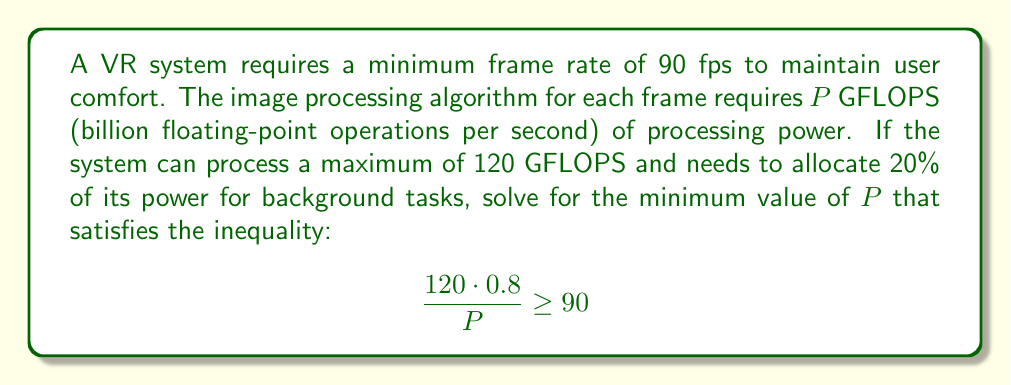Show me your answer to this math problem. Let's solve this step-by-step:

1) First, let's interpret the inequality:
   - 120 GFLOPS is the total processing power
   - 0.8 (or 80%) is the portion available for frame processing
   - $P$ is the processing power required per frame
   - The left side of the inequality represents frames per second
   - 90 is the minimum required frame rate

2) Simplify the left side of the inequality:
   $$\frac{120 \cdot 0.8}{P} \geq 90$$
   $$\frac{96}{P} \geq 90$$

3) Multiply both sides by $P$:
   $$96 \geq 90P$$

4) Divide both sides by 90:
   $$\frac{96}{90} \geq P$$

5) Simplify:
   $$1.0666... \geq P$$

6) Since we're looking for the minimum value of $P$ that satisfies this inequality, we take the upper bound of this result.

7) Round to 3 decimal places for practical purposes:
   $$P \leq 1.067$$

Therefore, the minimum value of $P$ is 1.067 GFLOPS per frame.
Answer: 1.067 GFLOPS 